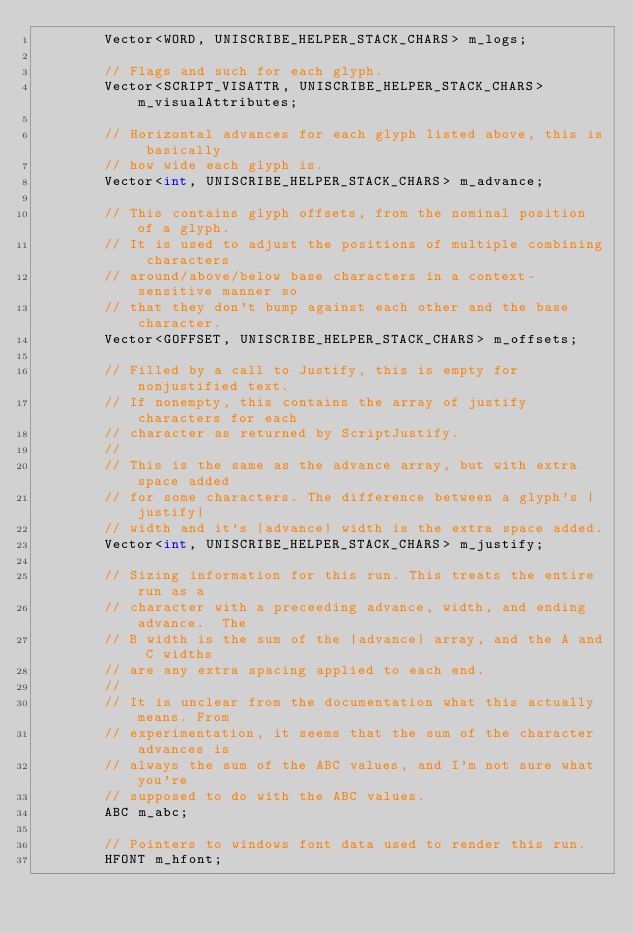<code> <loc_0><loc_0><loc_500><loc_500><_C_>        Vector<WORD, UNISCRIBE_HELPER_STACK_CHARS> m_logs;

        // Flags and such for each glyph.
        Vector<SCRIPT_VISATTR, UNISCRIBE_HELPER_STACK_CHARS> m_visualAttributes;

        // Horizontal advances for each glyph listed above, this is basically
        // how wide each glyph is.
        Vector<int, UNISCRIBE_HELPER_STACK_CHARS> m_advance;

        // This contains glyph offsets, from the nominal position of a glyph.
        // It is used to adjust the positions of multiple combining characters
        // around/above/below base characters in a context-sensitive manner so
        // that they don't bump against each other and the base character.
        Vector<GOFFSET, UNISCRIBE_HELPER_STACK_CHARS> m_offsets;

        // Filled by a call to Justify, this is empty for nonjustified text.
        // If nonempty, this contains the array of justify characters for each
        // character as returned by ScriptJustify.
        //
        // This is the same as the advance array, but with extra space added
        // for some characters. The difference between a glyph's |justify|
        // width and it's |advance| width is the extra space added.
        Vector<int, UNISCRIBE_HELPER_STACK_CHARS> m_justify;

        // Sizing information for this run. This treats the entire run as a
        // character with a preceeding advance, width, and ending advance.  The
        // B width is the sum of the |advance| array, and the A and C widths
        // are any extra spacing applied to each end.
        //
        // It is unclear from the documentation what this actually means. From
        // experimentation, it seems that the sum of the character advances is
        // always the sum of the ABC values, and I'm not sure what you're
        // supposed to do with the ABC values.
        ABC m_abc;

        // Pointers to windows font data used to render this run.
        HFONT m_hfont;</code> 